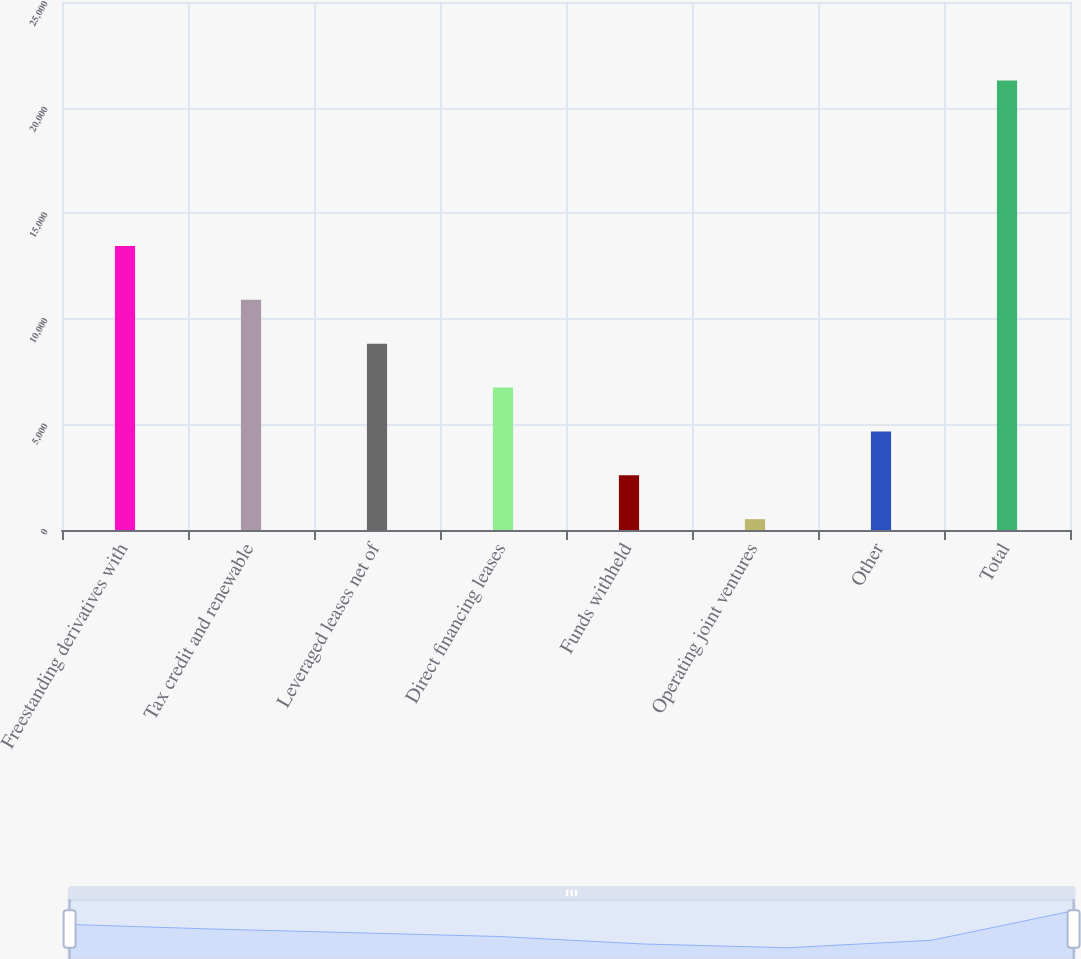Convert chart. <chart><loc_0><loc_0><loc_500><loc_500><bar_chart><fcel>Freestanding derivatives with<fcel>Tax credit and renewable<fcel>Leveraged leases net of<fcel>Direct financing leases<fcel>Funds withheld<fcel>Operating joint ventures<fcel>Other<fcel>Total<nl><fcel>13452<fcel>10898<fcel>8821<fcel>6744<fcel>2590<fcel>513<fcel>4667<fcel>21283<nl></chart> 